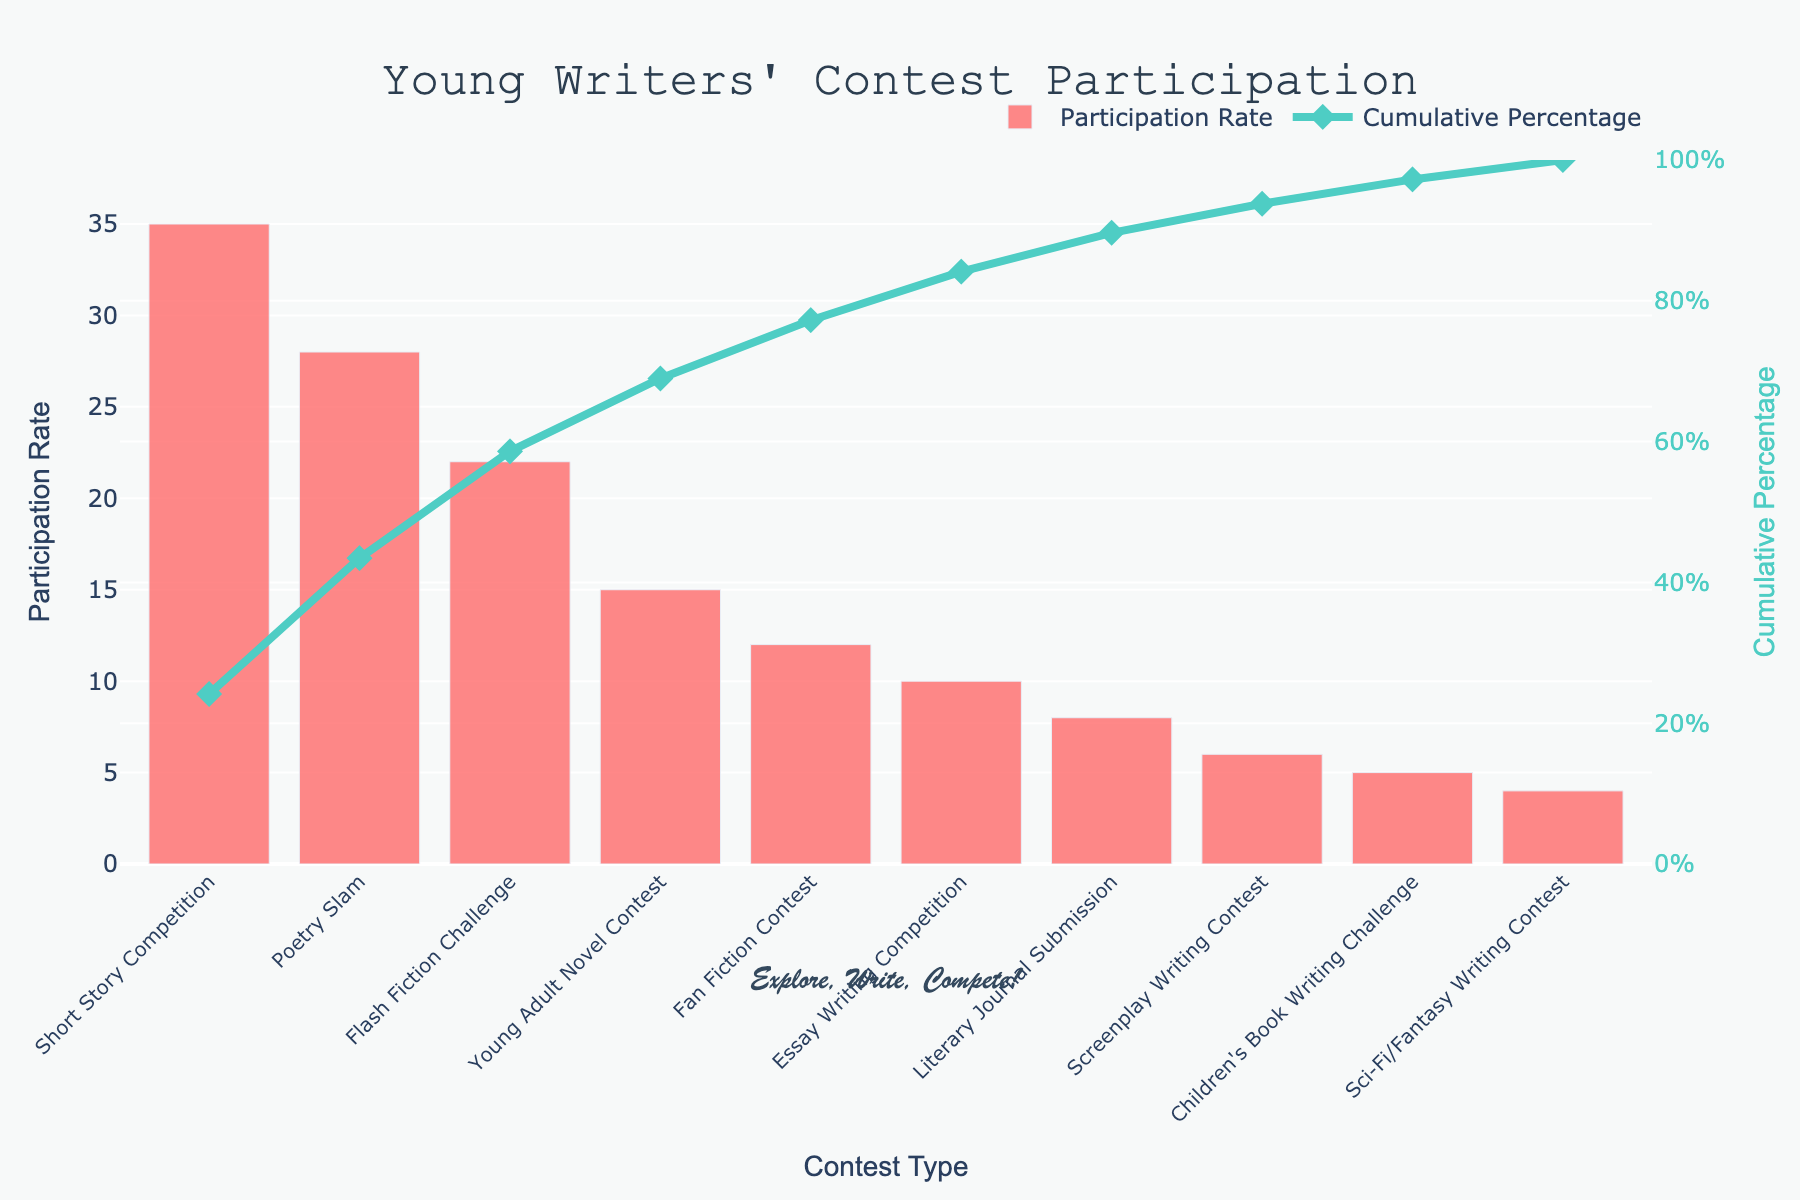What's the title of the Pareto chart? The title is typically displayed at the top of the chart. It reads "Young Writers' Contest Participation".
Answer: Young Writers' Contest Participation What is the participation rate for the "Poetry Slam"? Locate the bar representing "Poetry Slam" and read the value from the y-axis. The height of the "Poetry Slam" bar corresponds to a participation rate of 28.
Answer: 28 Which contest type has the highest participation rate? Identify which bar is the tallest. The "Short Story Competition" bar is the highest, indicating it has the highest participation rate.
Answer: Short Story Competition What is the cumulative percentage right after the "Young Adult Novel Contest"? Follow the line plot representing the cumulative percentage up to "Young Adult Novel Contest". Find where the line is at this point on the y2-axis. The cumulative percentage is 100% at this point.
Answer: 100% How many contest types have a participation rate above 20? Count the bars with a height above the 20 mark on the y-axis. There are three such bars: "Short Story Competition", "Poetry Slam", and "Flash Fiction Challenge".
Answer: 3 What is the difference in participation rate between "Flash Fiction Challenge" and "Fan Fiction Contest"? Subtract the participation rate of "Fan Fiction Contest" (12) from "Flash Fiction Challenge" (22). \(22 - 12 = 10\).
Answer: 10 Which two contest types have participation rates adding up to 45? Identify pairs of bars whose heights together sum to 45. "Poetry Slam" (28) and "Children's Book Writing Challenge" (5) sum up to 33, which isn't correct. However, "Flash Fiction Challenge" (22) and "Fan Fiction Contest" (12) sum up to 34, which also isn't it. Continue to identify correct pair.
Answer: Short Story Competition and Children's Book Writing Challenge At what rate does the cumulative percentage reach approximately 80%? Follow the cumulative percentage line and locate the point closest to 80% on the secondary y-axis. Check corresponding contest type and participation rate.
Answer: Flash Fiction Challenge List the contest types in order of decreasing participation rate. Refer to the sequence of bars from left to right. The order is: "Short Story Competition", "Poetry Slam", "Flash Fiction Challenge", "Young Adult Novel Contest", "Fan Fiction Contest", "Essay Writing Competition", "Literary Journal Submission", "Screenplay Writing Contest", "Children's Book Writing Challenge", and "Sci-Fi/Fantasy Writing Contest".
Answer: Exact listing in answer What percentage of contests have a participation rate less than 10%? Count the bars with heights below the 10 mark on the y-axis and divide by the total number of contests (bars). There are four such bars out of ten total, yielding a calculation \(4 / 10 * 100 = 40%\).
Answer: 40 